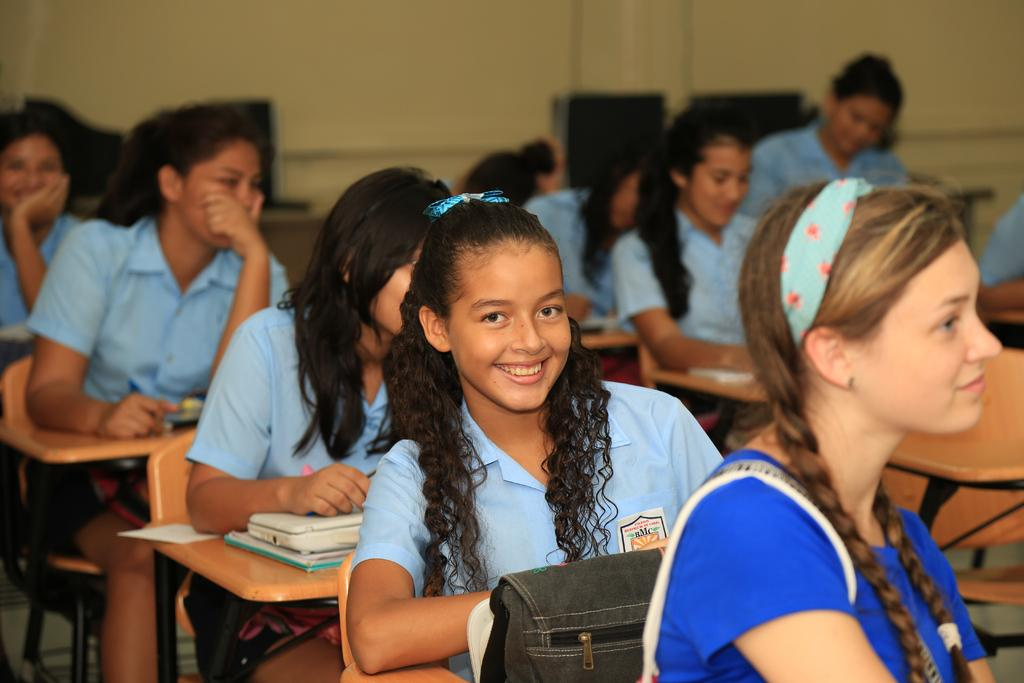How many women are sitting on chairs in the image? There are five women sitting on chairs in the image. What else can be seen in the image besides the women sitting on chairs? There is a bag and books on a table visible in the image. Can you describe the background of the image? There are other women sitting in the background, and there is a wall visible in the background. What type of cake is being served in the image? There is no cake present in the image. What time of day is it in the image? The time of day cannot be determined from the image. 